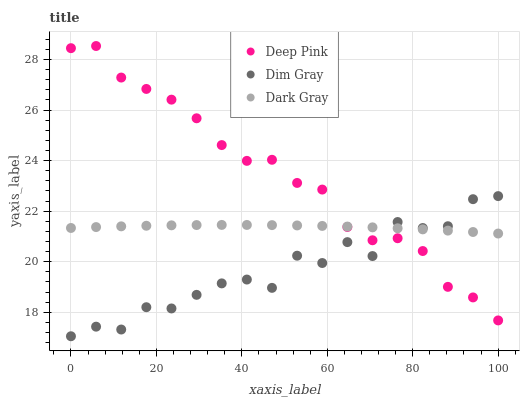Does Dim Gray have the minimum area under the curve?
Answer yes or no. Yes. Does Deep Pink have the maximum area under the curve?
Answer yes or no. Yes. Does Deep Pink have the minimum area under the curve?
Answer yes or no. No. Does Dim Gray have the maximum area under the curve?
Answer yes or no. No. Is Dark Gray the smoothest?
Answer yes or no. Yes. Is Dim Gray the roughest?
Answer yes or no. Yes. Is Deep Pink the smoothest?
Answer yes or no. No. Is Deep Pink the roughest?
Answer yes or no. No. Does Dim Gray have the lowest value?
Answer yes or no. Yes. Does Deep Pink have the lowest value?
Answer yes or no. No. Does Deep Pink have the highest value?
Answer yes or no. Yes. Does Dim Gray have the highest value?
Answer yes or no. No. Does Dim Gray intersect Dark Gray?
Answer yes or no. Yes. Is Dim Gray less than Dark Gray?
Answer yes or no. No. Is Dim Gray greater than Dark Gray?
Answer yes or no. No. 